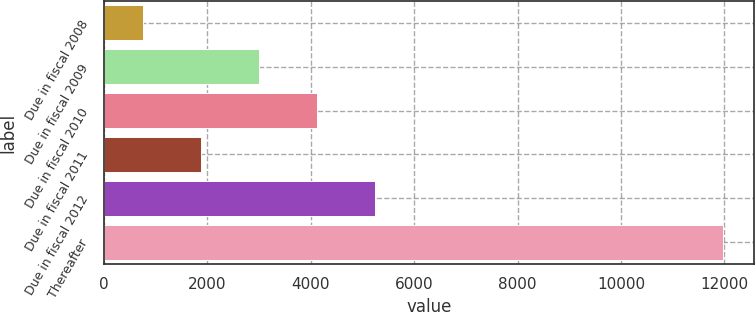Convert chart to OTSL. <chart><loc_0><loc_0><loc_500><loc_500><bar_chart><fcel>Due in fiscal 2008<fcel>Due in fiscal 2009<fcel>Due in fiscal 2010<fcel>Due in fiscal 2011<fcel>Due in fiscal 2012<fcel>Thereafter<nl><fcel>757<fcel>3001.2<fcel>4123.3<fcel>1879.1<fcel>5245.4<fcel>11978<nl></chart> 